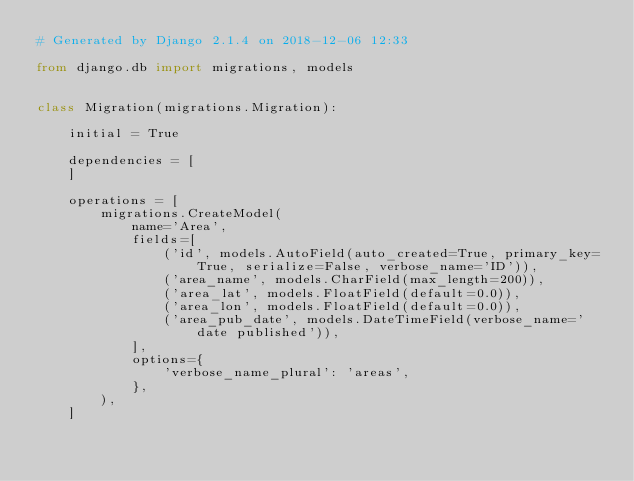<code> <loc_0><loc_0><loc_500><loc_500><_Python_># Generated by Django 2.1.4 on 2018-12-06 12:33

from django.db import migrations, models


class Migration(migrations.Migration):

    initial = True

    dependencies = [
    ]

    operations = [
        migrations.CreateModel(
            name='Area',
            fields=[
                ('id', models.AutoField(auto_created=True, primary_key=True, serialize=False, verbose_name='ID')),
                ('area_name', models.CharField(max_length=200)),
                ('area_lat', models.FloatField(default=0.0)),
                ('area_lon', models.FloatField(default=0.0)),
                ('area_pub_date', models.DateTimeField(verbose_name='date published')),
            ],
            options={
                'verbose_name_plural': 'areas',
            },
        ),
    ]
</code> 